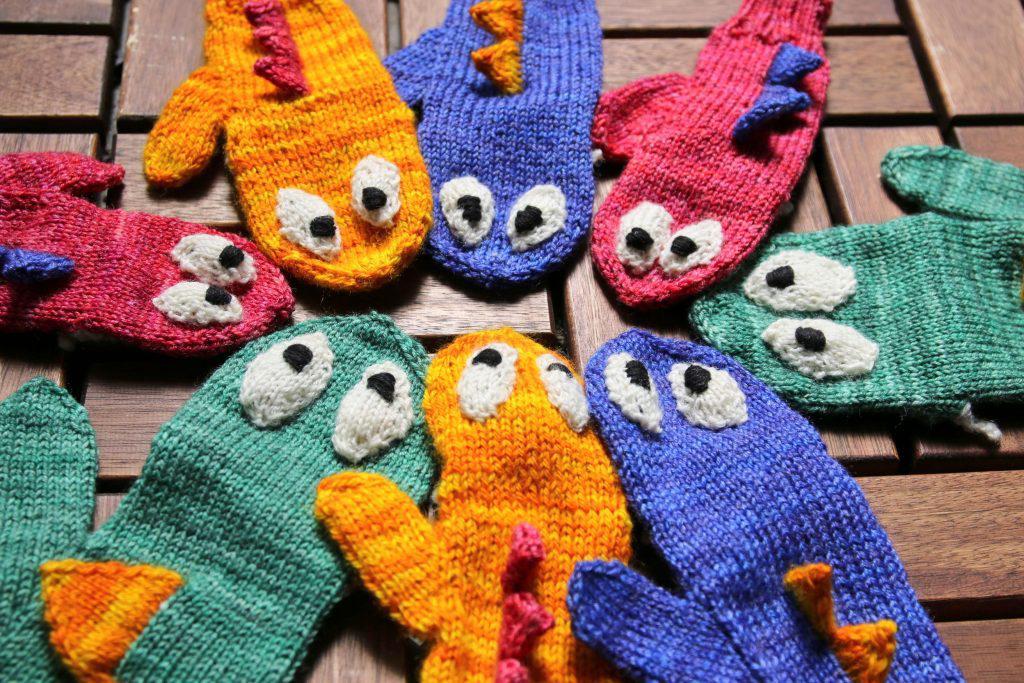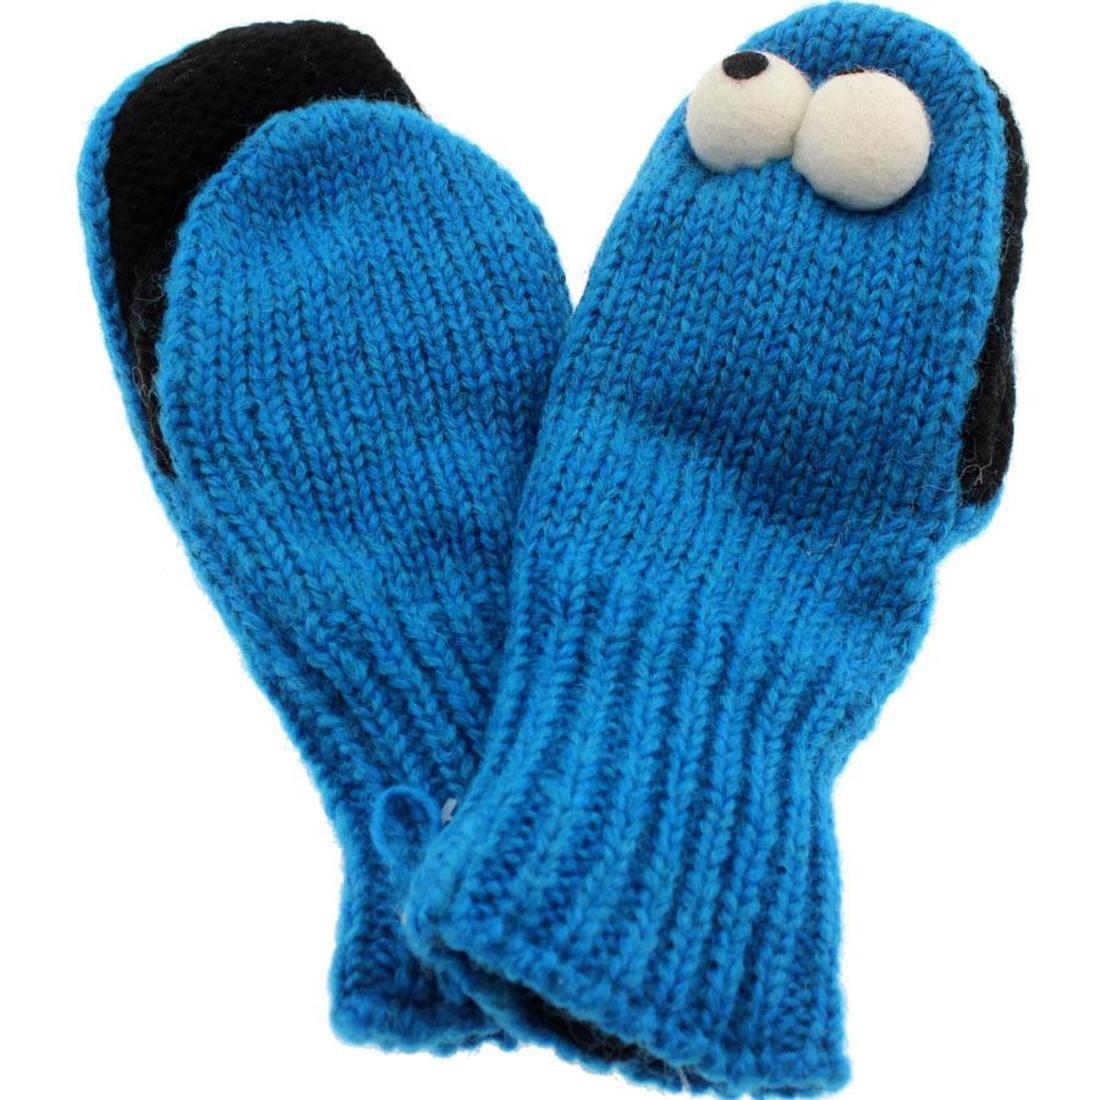The first image is the image on the left, the second image is the image on the right. Examine the images to the left and right. Is the description "there are at least two pairs of mittens in the image on the left" accurate? Answer yes or no. Yes. 